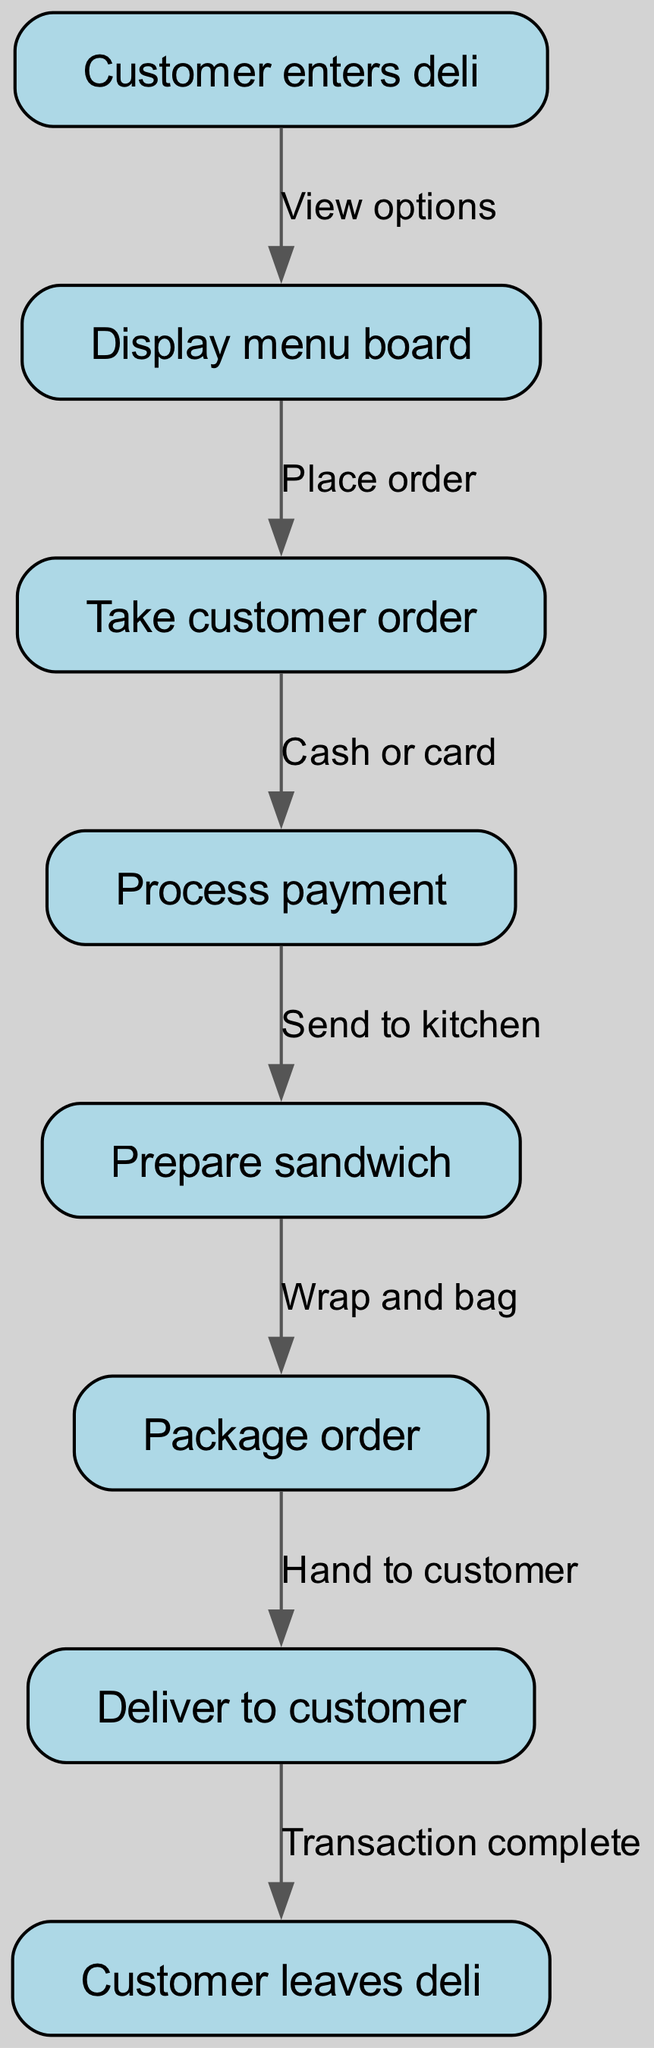What is the first step in the customer order processing system? The first step in the flowchart is represented by the node labeled "Customer enters deli." This indicates that the process starts when a customer arrives at the deli.
Answer: Customer enters deli How many nodes are present in the diagram? By counting the number of distinct nodes listed in the data, we find there are a total of eight nodes: start, menu, order, payment, prepare, package, deliver, and end.
Answer: 8 What action occurs just before the customer pays for their order? According to the edges connecting the nodes, the action directly preceding payment is "Take customer order." Therefore, the order must be taken before payment can be processed.
Answer: Take customer order Which node follows the "Prepare sandwich" step? The flow from the "Prepare sandwich" node leads to the next node, "Package order." This shows that packaging comes immediately after preparing the sandwich.
Answer: Package order What text is used to highlight the interaction between "Package order" and "Deliver to customer"? The edge connecting these two nodes carries the text "Hand to customer." This indicates that once the order is packaged, it is handed over to the customer.
Answer: Hand to customer What type of payment is accepted in the process? The flowchart indicates that payment can be made via "Cash or card," which shows that both forms of payment are accepted in the system.
Answer: Cash or card What is the final step that a customer takes after receiving their order? The last action in the flowchart is represented by the node "Customer leaves deli," which identifies that the process concludes with the customer departing from the deli.
Answer: Customer leaves deli How does a customer view their options in the deli? The flowchart specifies that customers view their options by interacting with the "Display menu board" node, which is the step that follows entering the deli.
Answer: Display menu board What action is taken after processing payment? Following the payment, the next action described in the flowchart is to "Prepare sandwich," indicating that the order is then made after payment has been completed.
Answer: Prepare sandwich 